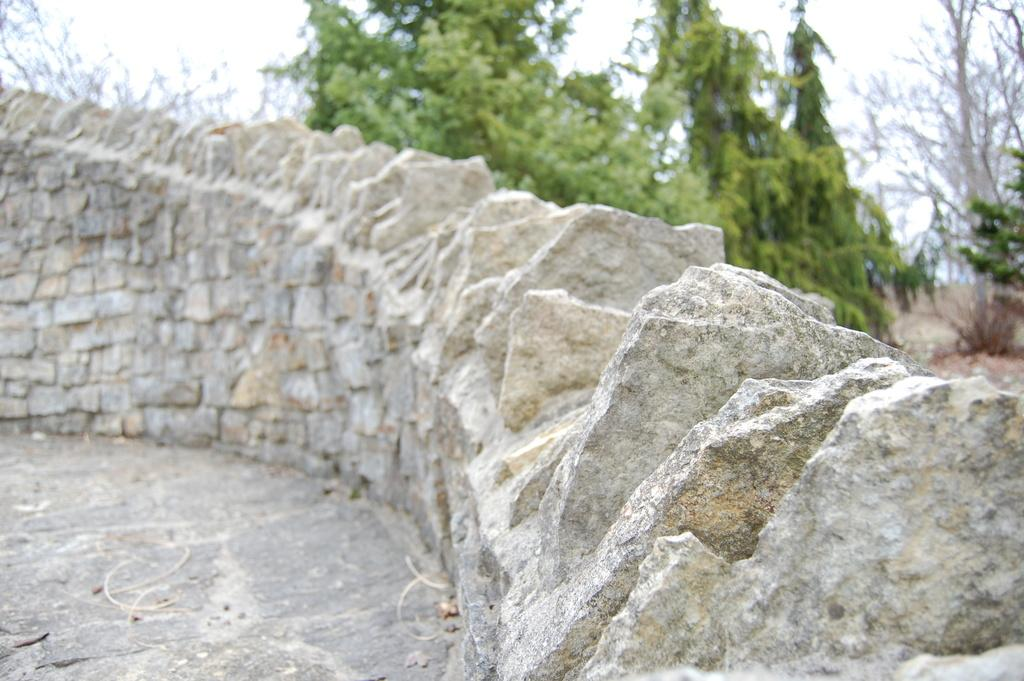What type of wall is present in the front side of the image? There is a granite parapet wall in the front side of the image. What can be seen behind the wall in the image? There are trees visible behind the wall in the image. What type of liquid is being poured on the wall in the image? There is no liquid being poured on the wall in the image. Is there a plough visible in the image? There is no plough present in the image. 